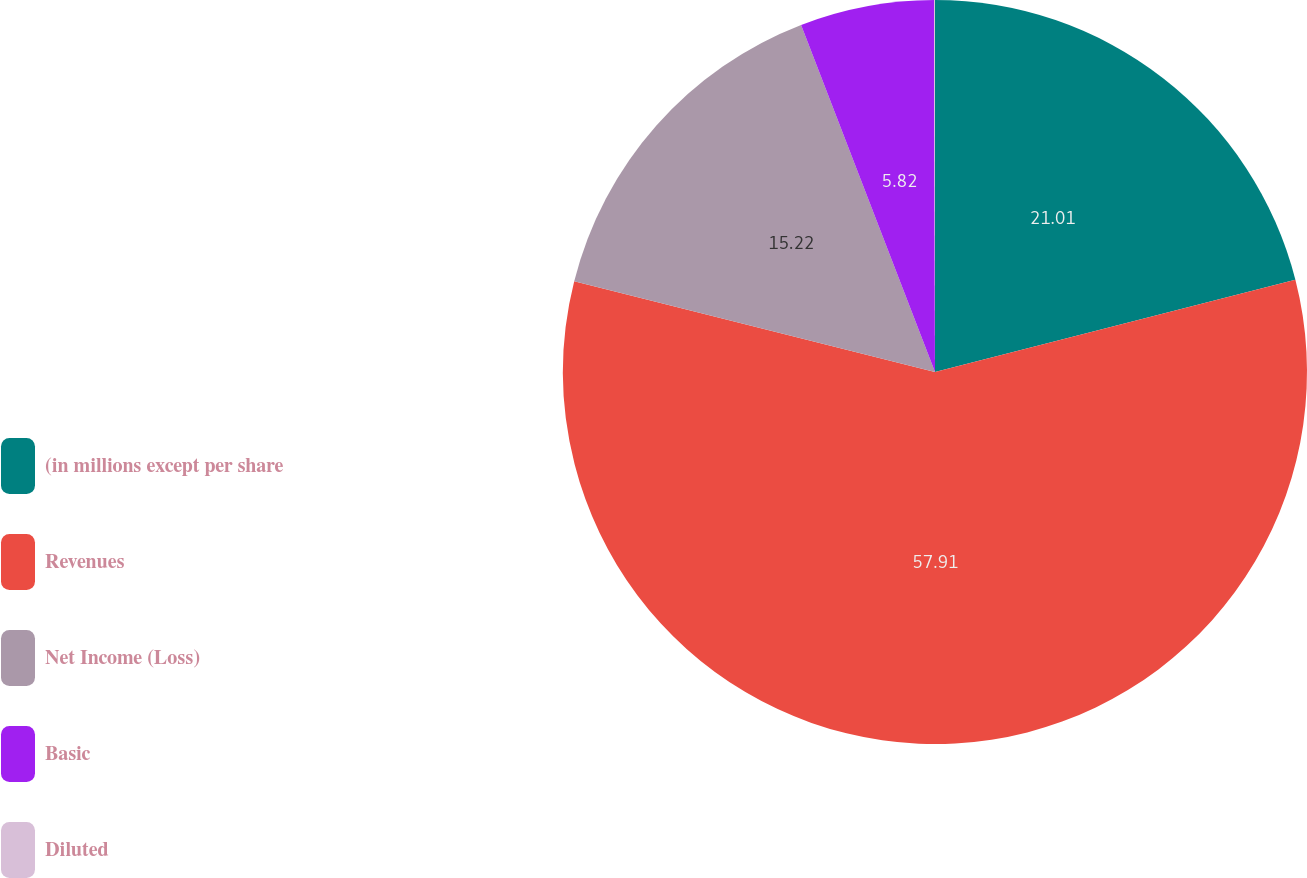<chart> <loc_0><loc_0><loc_500><loc_500><pie_chart><fcel>(in millions except per share<fcel>Revenues<fcel>Net Income (Loss)<fcel>Basic<fcel>Diluted<nl><fcel>21.01%<fcel>57.9%<fcel>15.22%<fcel>5.82%<fcel>0.04%<nl></chart> 